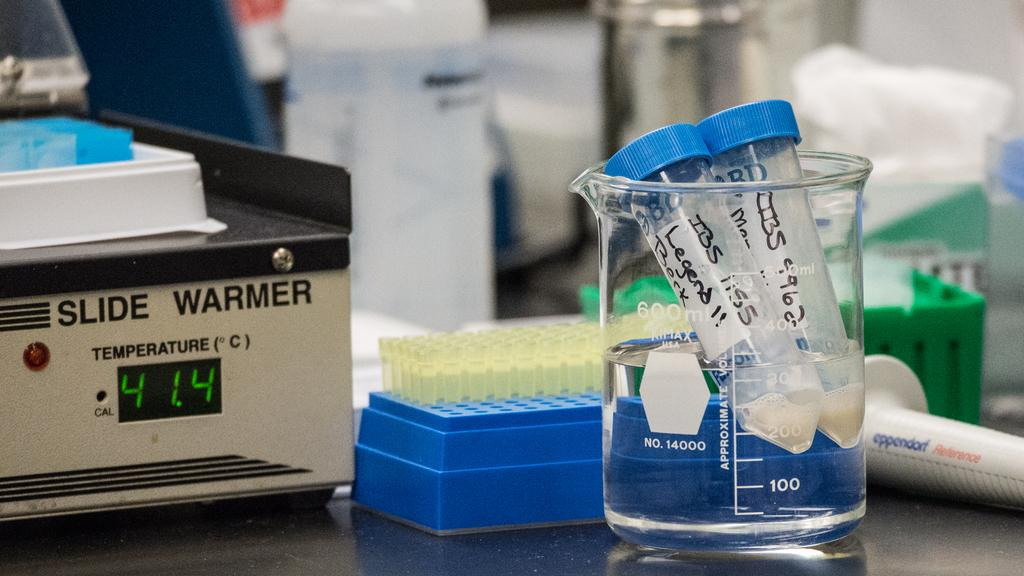<image>
Describe the image concisely. an object that is called a slide warmer next to other items 